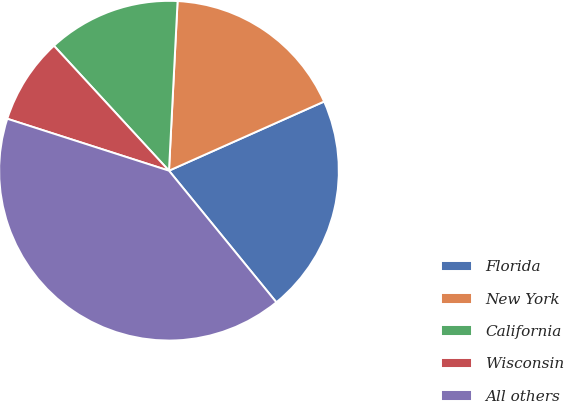Convert chart to OTSL. <chart><loc_0><loc_0><loc_500><loc_500><pie_chart><fcel>Florida<fcel>New York<fcel>California<fcel>Wisconsin<fcel>All others<nl><fcel>20.78%<fcel>17.52%<fcel>12.65%<fcel>8.21%<fcel>40.84%<nl></chart> 